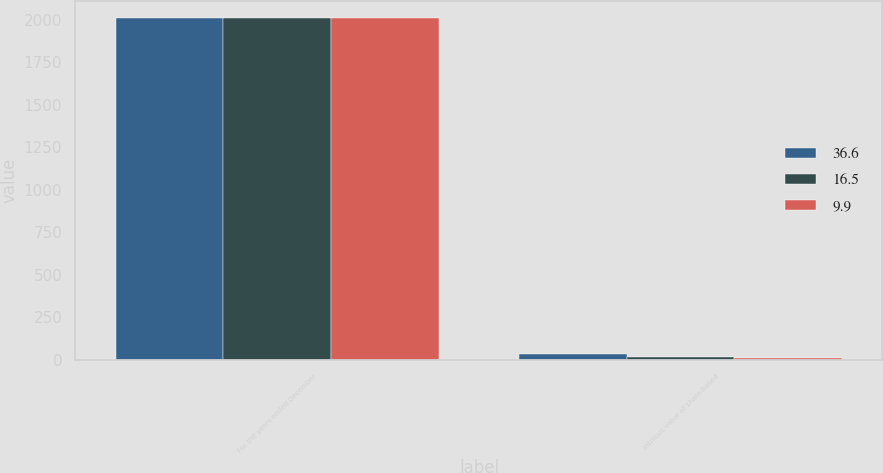<chart> <loc_0><loc_0><loc_500><loc_500><stacked_bar_chart><ecel><fcel>For the years ended December<fcel>Intrinsic value of share-based<nl><fcel>36.6<fcel>2011<fcel>36.6<nl><fcel>16.5<fcel>2010<fcel>16.5<nl><fcel>9.9<fcel>2009<fcel>9.9<nl></chart> 